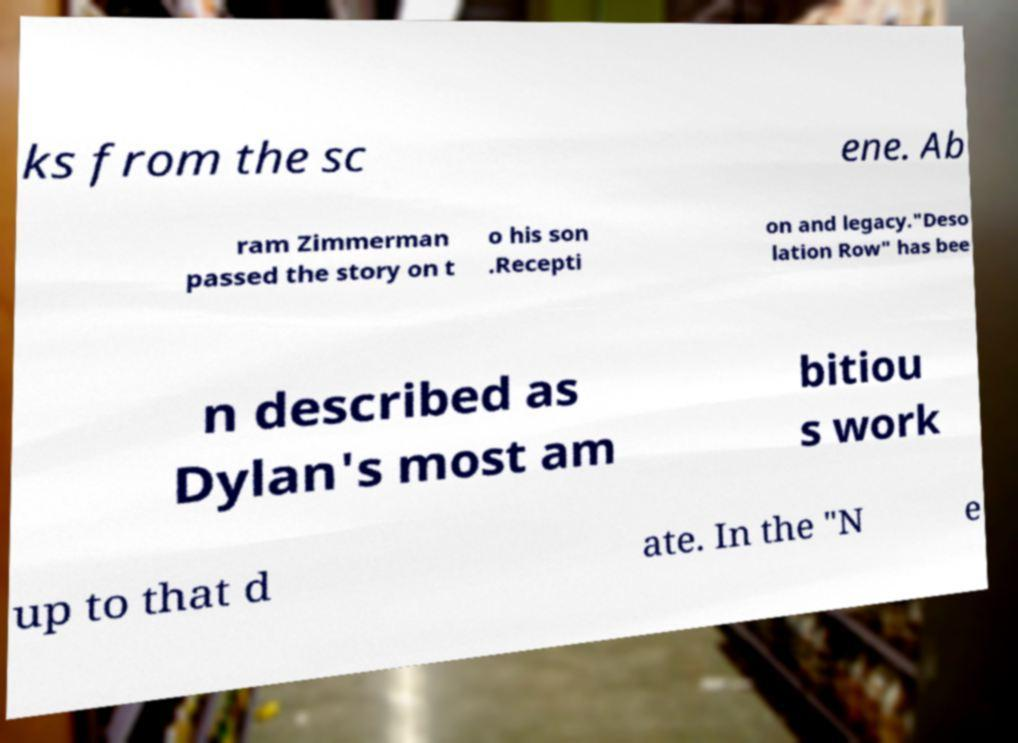Please identify and transcribe the text found in this image. ks from the sc ene. Ab ram Zimmerman passed the story on t o his son .Recepti on and legacy."Deso lation Row" has bee n described as Dylan's most am bitiou s work up to that d ate. In the "N e 